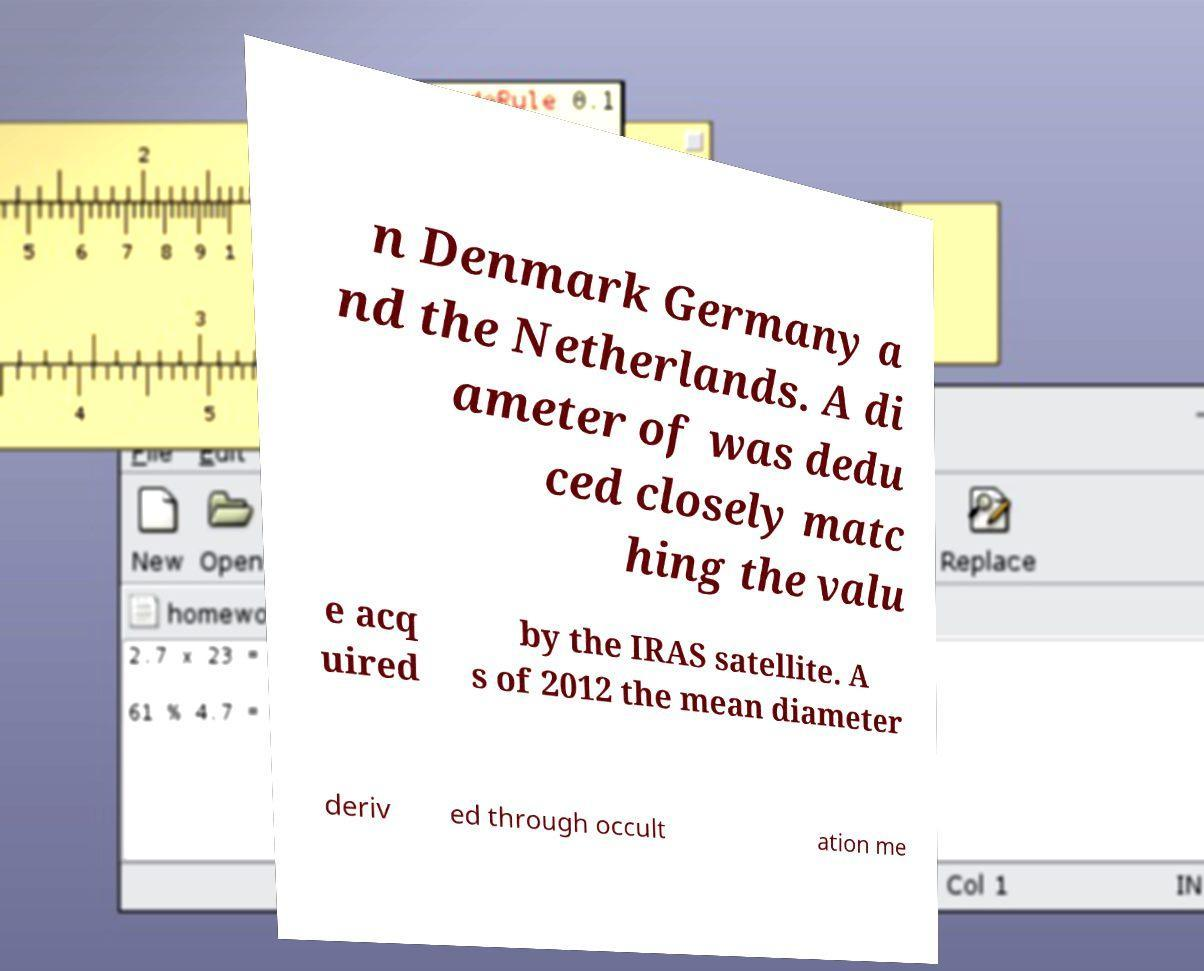Can you read and provide the text displayed in the image?This photo seems to have some interesting text. Can you extract and type it out for me? n Denmark Germany a nd the Netherlands. A di ameter of was dedu ced closely matc hing the valu e acq uired by the IRAS satellite. A s of 2012 the mean diameter deriv ed through occult ation me 